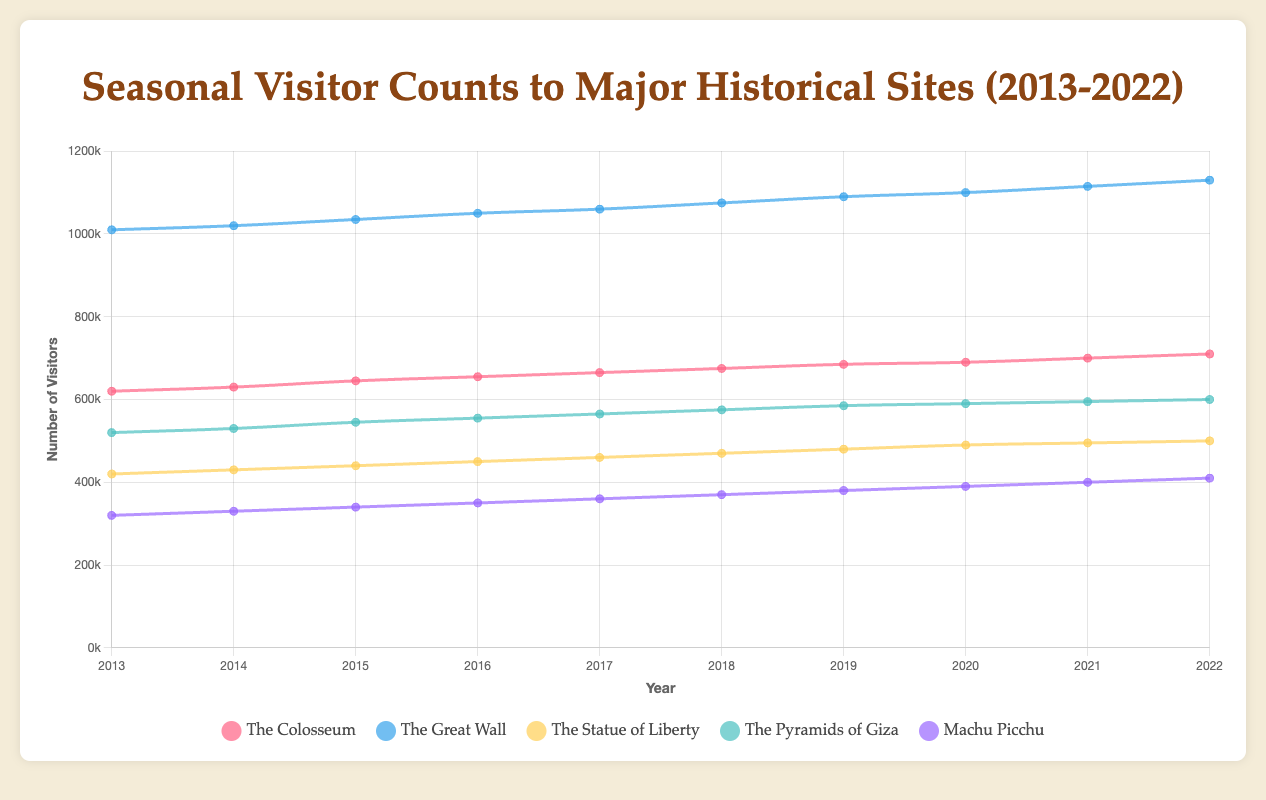How many visitors did The Colosseum have in spring over the ten years? To find the total number of visitors in spring over the ten years for The Colosseum, sum the spring visitor counts from each year: 485000 + 495000 + 510000 + 530000 + 540000 + 550000 + 560000 + 570000 + 580000 + 590000. This yields a total of 5415000.
Answer: 5415000 Which historical site had the highest number of visitors in summer in 2022? To determine this, compare the summer visitor counts of all five historical sites in 2022: The Colosseum (710000), The Great Wall (1130000), The Statue of Liberty (500000), The Pyramids of Giza (600000), and Machu Picchu (410000). The Great Wall had the highest number of visitors.
Answer: The Great Wall Which years show the least and greatest change in visitor count during summer at Machu Picchu? Calculate the changes for each year: 2014-2013 (330000-320000 = 10000), 2015-2014 (340000-330000 = 10000), 2016-2015 (350000-340000 = 10000), 2017-2016 (360000-350000 = 10000), 2018-2017 (370000-360000 = 10000), 2019-2018 (380000-370000 = 10000), 2020-2019 (390000-380000 = 10000), 2021-2020 (400000-390000 = 10000), 2022-2021 (410000-400000 = 10000). The changes are all the same, so all years had equal changes.
Answer: Every year had equal change What is the average annual summer visitor count at The Statue of Liberty from 2013 to 2022? To find the average, sum the summer visitor counts and divide by the number of years: (420000 + 430000 + 440000 + 450000 + 460000 + 470000 + 480000 + 490000 + 495000 + 500000) / 10 = 4535000 / 10 = 453500.
Answer: 453500 Which season consistently had the highest visitor counts for The Pyramids of Giza? By comparing the visitor counts for each season over the years, it is clear that summer (consistently over 500000, reaching up to 600000) had the highest visitor counts, compared to spring, fall, and winter.
Answer: Summer Between 2013 and 2022, in which year did The Great Wall see the highest total annual visitor count? Sum up the visitor counts for each season for each year and compare: 2013 (850000 + 1010000 + 910000 + 620000 = 3390000), 2014 (860000 + 1020000 + 920000 + 630000 = 3430000), 2015 (870000 + 1035000 + 930000 + 640000 = 3475000), 2016 (880000 + 1050000 + 940000 + 650000 = 3520000), 2017 (895000 + 1060000 + 950000 + 660000 = 3565000), 2018 (910000 + 1075000 + 960000 + 670000 = 3610000), 2019 (920000 + 1090000 + 970000 + 680000 = 3640000), 2020 (930000 + 1100000 + 980000 + 690000 = 3700000), 2021 (940000 + 1115000 + 990000 + 700000 = 3745000), 2022 (950000 + 1130000 + 1000000 + 710000 = 3790000). The highest total annual visitor count was in 2022.
Answer: 2022 In 2021, how many more visitors did The Great Wall have in summer compared to The Colosseum in the same season? Subtract the summer visitor count of The Colosseum (700000) from that of The Great Wall (1115000): 1115000 - 700000 = 415000.
Answer: 415000 Considering The Statue of Liberty, during which year did the winter season see the smallest visitor count between 2013 and 2022? Reviewing the winter visitor counts over the years: 2013 (210000), 2014 (220000), 2015 (230000), 2016 (240000), 2017 (250000), 2018 (260000), 2019 (270000), 2020 (275000), 2021 (280000), 2022 (285000), it is evident that 2013 had the smallest visitor count in winter.
Answer: 2013 